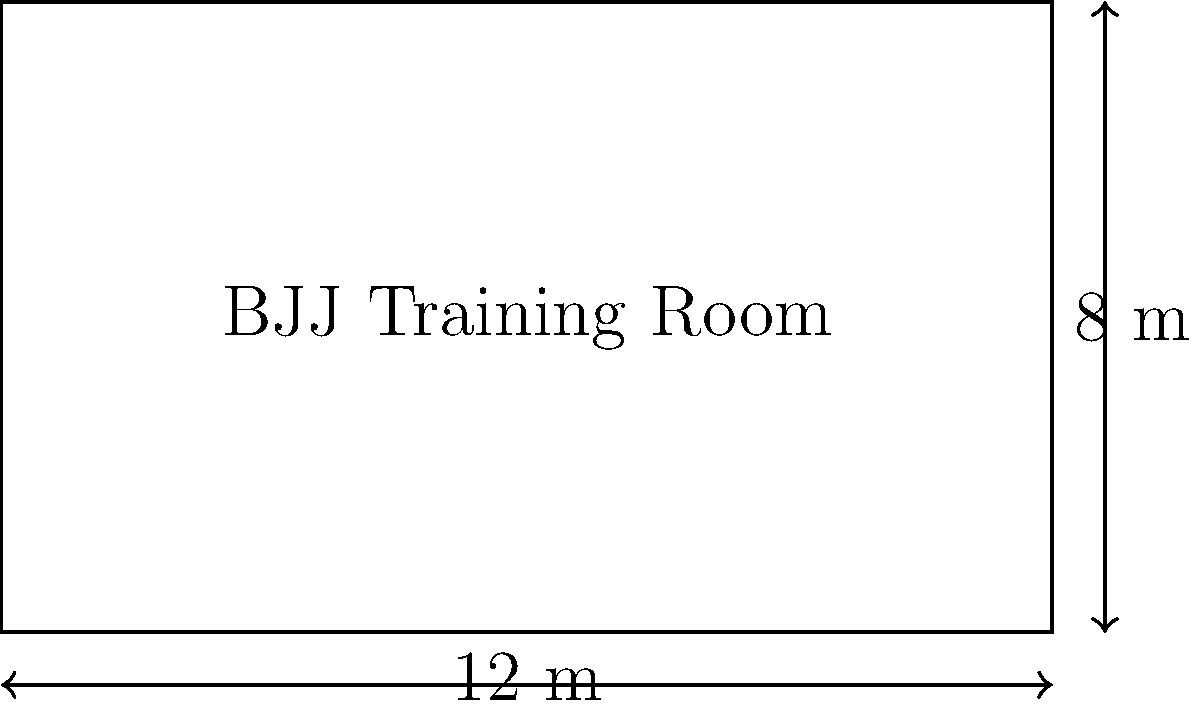You're super excited about your new BJJ training room! The rectangular room measures 12 meters in length and 8 meters in width. What is the total area of the training room where you'll be practicing your awesome moves? Let's break this down step-by-step:

1. We know that the room is rectangular, so we can use the formula for the area of a rectangle:
   $$ A = l \times w $$
   where $A$ is the area, $l$ is the length, and $w$ is the width.

2. We're given:
   - Length ($l$) = 12 meters
   - Width ($w$) = 8 meters

3. Now, let's plug these values into our formula:
   $$ A = 12 \text{ m} \times 8 \text{ m} $$

4. Multiply the numbers:
   $$ A = 96 \text{ m}^2 $$

5. Therefore, the total area of your BJJ training room is 96 square meters.

This means you have 96 square meters of mat space to practice your guard passes, submissions, and other cool techniques!
Answer: $96 \text{ m}^2$ 